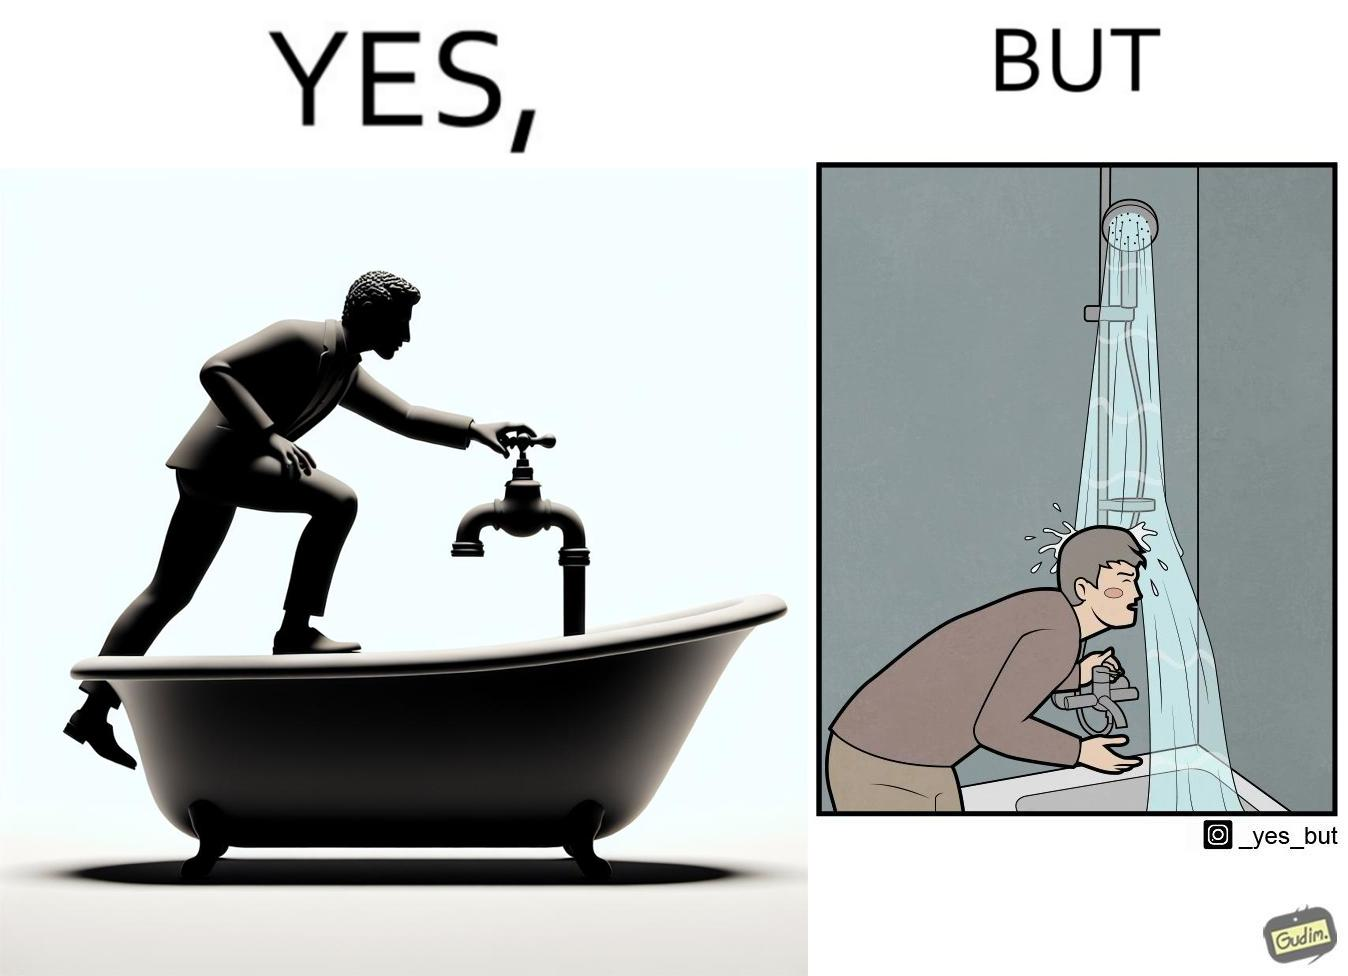Explain why this image is satirical. The image is funny, as the person is trying to operate the tap, but water comes out of the handheld shower resting on a holder instead of the tap, making the person drenched in water. 